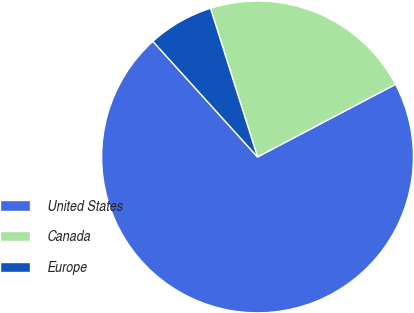Convert chart to OTSL. <chart><loc_0><loc_0><loc_500><loc_500><pie_chart><fcel>United States<fcel>Canada<fcel>Europe<nl><fcel>71.0%<fcel>22.17%<fcel>6.83%<nl></chart> 